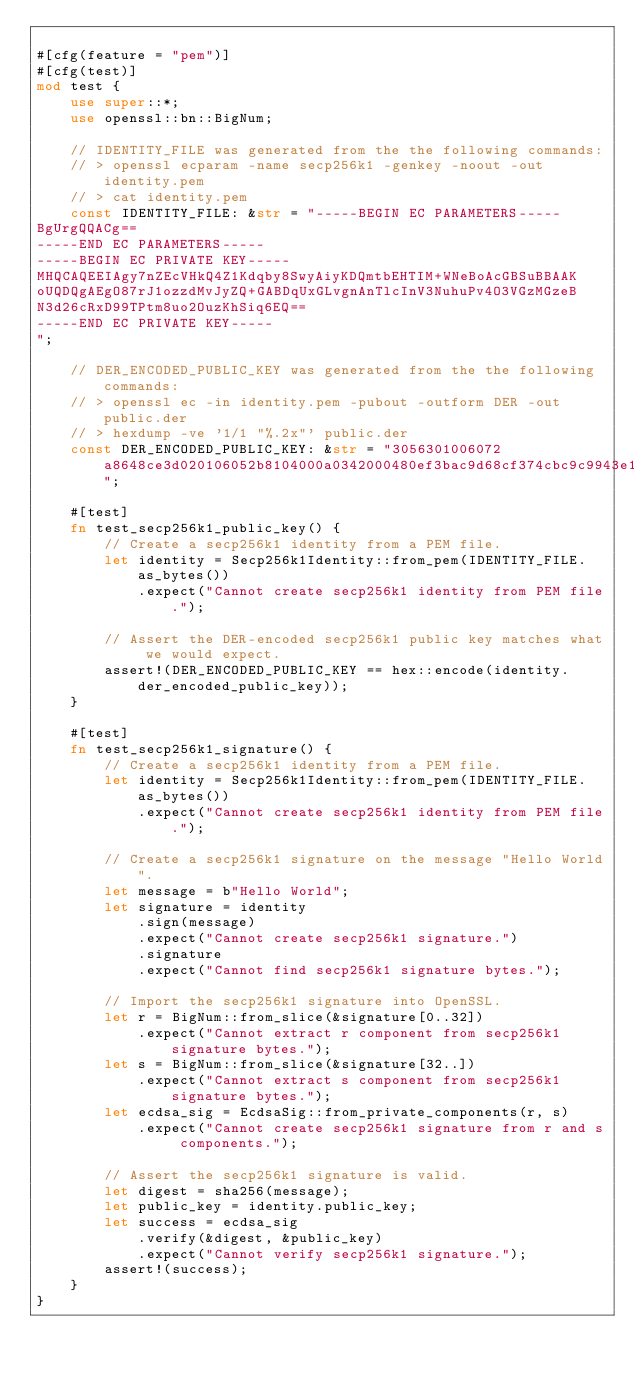Convert code to text. <code><loc_0><loc_0><loc_500><loc_500><_Rust_>
#[cfg(feature = "pem")]
#[cfg(test)]
mod test {
    use super::*;
    use openssl::bn::BigNum;

    // IDENTITY_FILE was generated from the the following commands:
    // > openssl ecparam -name secp256k1 -genkey -noout -out identity.pem
    // > cat identity.pem
    const IDENTITY_FILE: &str = "-----BEGIN EC PARAMETERS-----
BgUrgQQACg==
-----END EC PARAMETERS-----
-----BEGIN EC PRIVATE KEY-----
MHQCAQEEIAgy7nZEcVHkQ4Z1Kdqby8SwyAiyKDQmtbEHTIM+WNeBoAcGBSuBBAAK
oUQDQgAEgO87rJ1ozzdMvJyZQ+GABDqUxGLvgnAnTlcInV3NuhuPv4O3VGzMGzeB
N3d26cRxD99TPtm8uo2OuzKhSiq6EQ==
-----END EC PRIVATE KEY-----
";

    // DER_ENCODED_PUBLIC_KEY was generated from the the following commands:
    // > openssl ec -in identity.pem -pubout -outform DER -out public.der
    // > hexdump -ve '1/1 "%.2x"' public.der
    const DER_ENCODED_PUBLIC_KEY: &str = "3056301006072a8648ce3d020106052b8104000a0342000480ef3bac9d68cf374cbc9c9943e180043a94c462ef8270274e57089d5dcdba1b8fbf83b7546ccc1b3781377776e9c4710fdf533ed9bcba8d8ebb32a14a2aba11";

    #[test]
    fn test_secp256k1_public_key() {
        // Create a secp256k1 identity from a PEM file.
        let identity = Secp256k1Identity::from_pem(IDENTITY_FILE.as_bytes())
            .expect("Cannot create secp256k1 identity from PEM file.");

        // Assert the DER-encoded secp256k1 public key matches what we would expect.
        assert!(DER_ENCODED_PUBLIC_KEY == hex::encode(identity.der_encoded_public_key));
    }

    #[test]
    fn test_secp256k1_signature() {
        // Create a secp256k1 identity from a PEM file.
        let identity = Secp256k1Identity::from_pem(IDENTITY_FILE.as_bytes())
            .expect("Cannot create secp256k1 identity from PEM file.");

        // Create a secp256k1 signature on the message "Hello World".
        let message = b"Hello World";
        let signature = identity
            .sign(message)
            .expect("Cannot create secp256k1 signature.")
            .signature
            .expect("Cannot find secp256k1 signature bytes.");

        // Import the secp256k1 signature into OpenSSL.
        let r = BigNum::from_slice(&signature[0..32])
            .expect("Cannot extract r component from secp256k1 signature bytes.");
        let s = BigNum::from_slice(&signature[32..])
            .expect("Cannot extract s component from secp256k1 signature bytes.");
        let ecdsa_sig = EcdsaSig::from_private_components(r, s)
            .expect("Cannot create secp256k1 signature from r and s components.");

        // Assert the secp256k1 signature is valid.
        let digest = sha256(message);
        let public_key = identity.public_key;
        let success = ecdsa_sig
            .verify(&digest, &public_key)
            .expect("Cannot verify secp256k1 signature.");
        assert!(success);
    }
}
</code> 